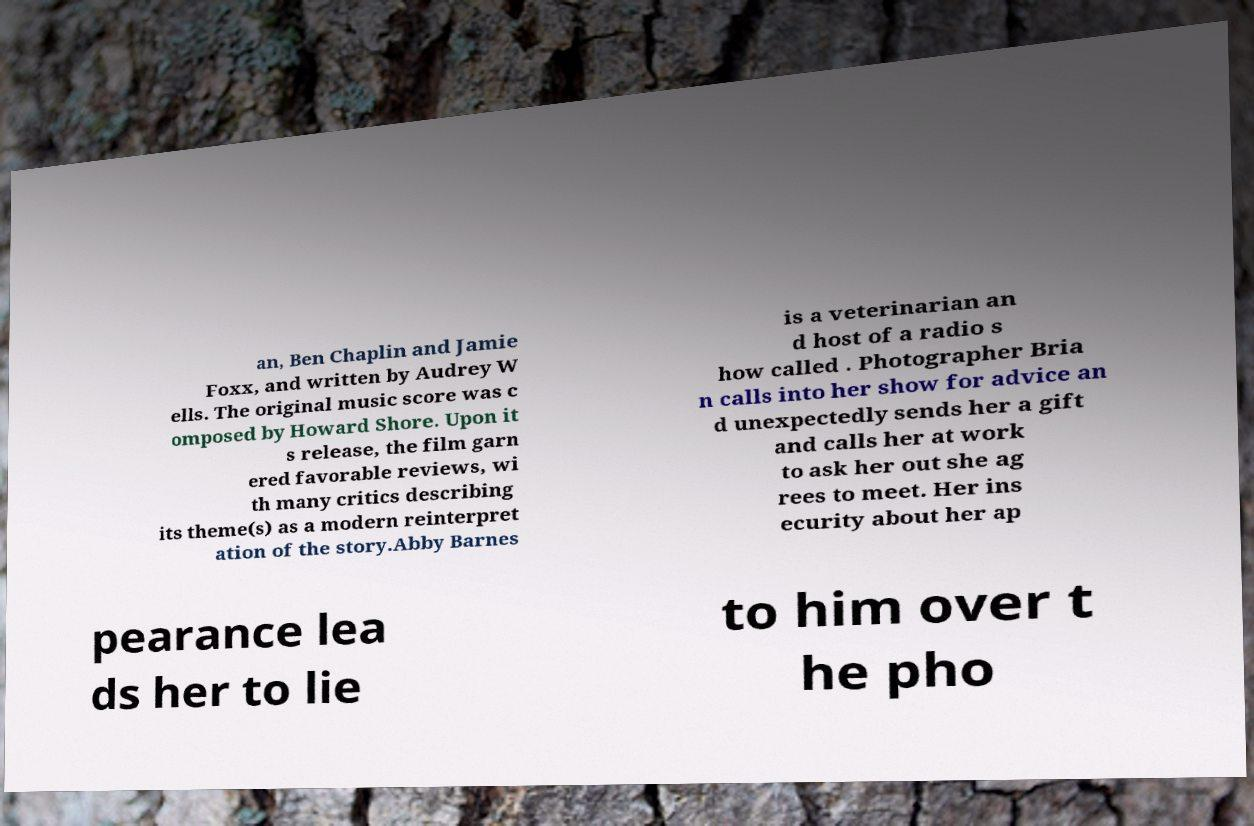Could you extract and type out the text from this image? an, Ben Chaplin and Jamie Foxx, and written by Audrey W ells. The original music score was c omposed by Howard Shore. Upon it s release, the film garn ered favorable reviews, wi th many critics describing its theme(s) as a modern reinterpret ation of the story.Abby Barnes is a veterinarian an d host of a radio s how called . Photographer Bria n calls into her show for advice an d unexpectedly sends her a gift and calls her at work to ask her out she ag rees to meet. Her ins ecurity about her ap pearance lea ds her to lie to him over t he pho 